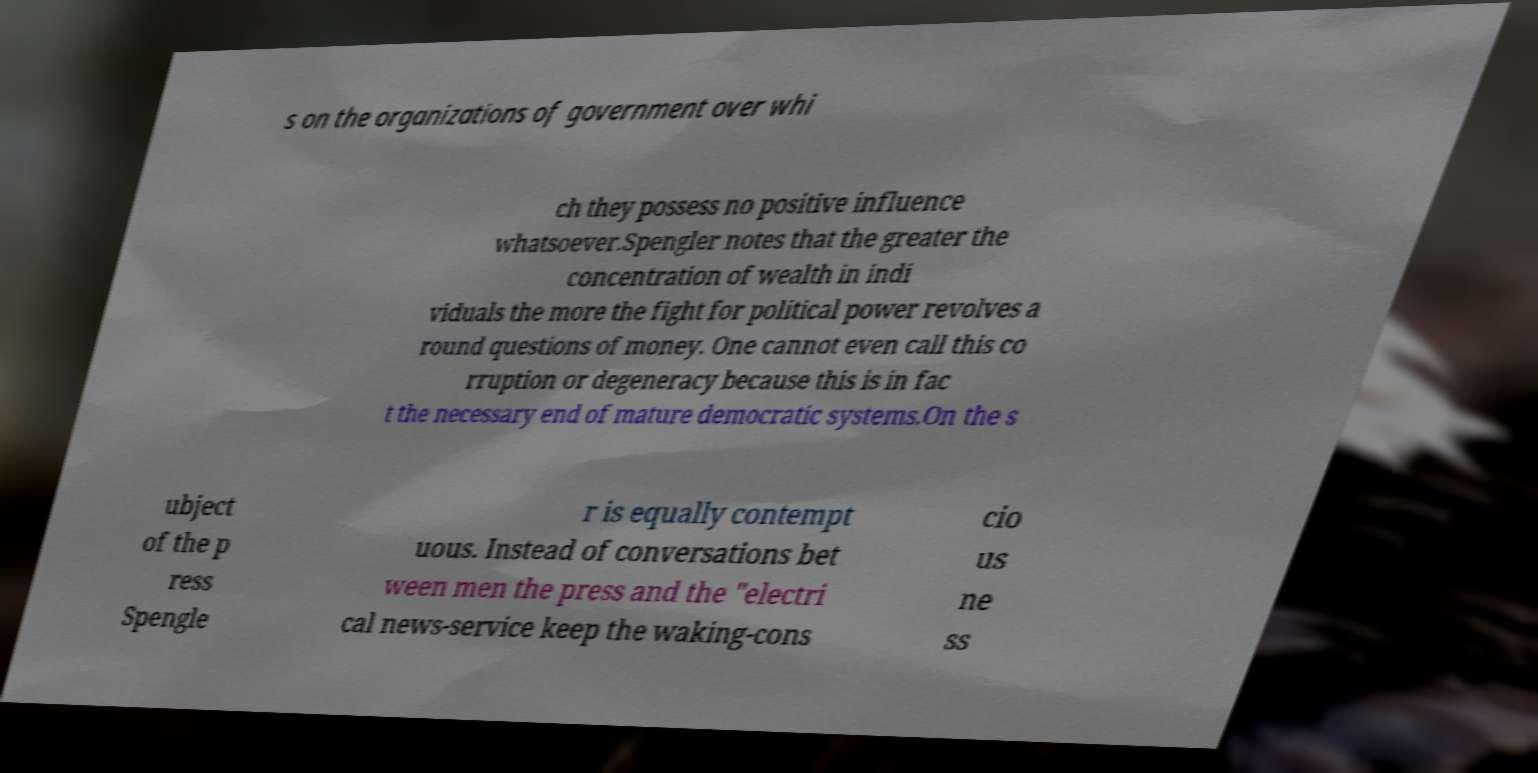Please identify and transcribe the text found in this image. s on the organizations of government over whi ch they possess no positive influence whatsoever.Spengler notes that the greater the concentration of wealth in indi viduals the more the fight for political power revolves a round questions of money. One cannot even call this co rruption or degeneracy because this is in fac t the necessary end of mature democratic systems.On the s ubject of the p ress Spengle r is equally contempt uous. Instead of conversations bet ween men the press and the "electri cal news-service keep the waking-cons cio us ne ss 